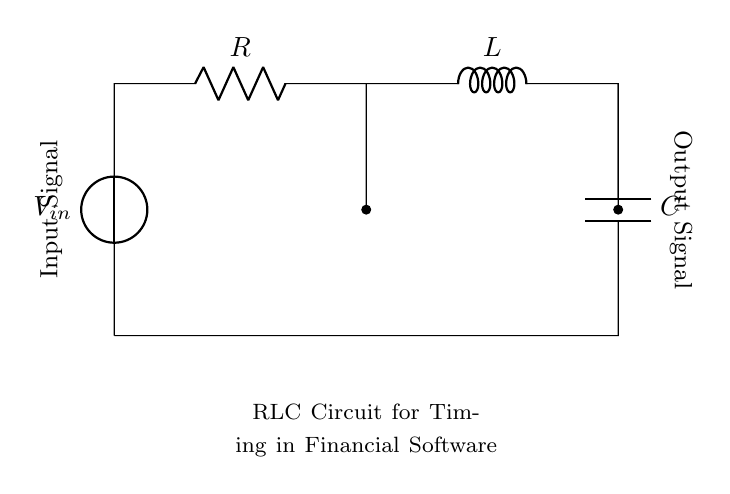What is the input voltage of this circuit? The input voltage is labeled as V_in on the voltage source in the circuit diagram, indicating the power supplied to the circuit.
Answer: V_in What components are in this circuit? The components are identified by their symbols in the circuit diagram: a voltage source, resistor, inductor, and capacitor.
Answer: Voltage source, resistor, inductor, capacitor What does the output signal represent? The output signal, marked at the end of the circuit, represents the result of the signal conditioned by the RLC circuit, which processes the input for timing purposes in financial software.
Answer: Resultant signal What is the role of the resistor in this circuit? The resistor limits the current flowing through the circuit and influences the time constant of the timing mechanism, affecting how quickly the circuit responds to the input signal.
Answer: Current limiting Which component affects the timing characteristics of the circuit the most? In an RLC circuit, the interplay of the resistor, inductor, and capacitor determines the timing characteristics, but the inductor primarily affects the timing due to its reactance in response to changes in current.
Answer: Inductor How does the capacitor function in this circuit? The capacitor stores and releases electrical energy, smoothing out fluctuations to help stabilize the output signal, which is critical for timing accuracy in applications like financial software.
Answer: Energy storage What is the net effect of combining R, L, and C in this circuit? The combination of the resistor, inductor, and capacitor creates a specific resonant frequency that determines how the circuit responds to the input signal, crucial for precise timing in applications.
Answer: Resonant frequency 